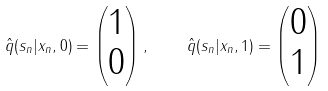<formula> <loc_0><loc_0><loc_500><loc_500>\hat { q } ( s _ { n } | x _ { n } , 0 ) = \begin{pmatrix} 1 \\ 0 \end{pmatrix} , \quad \hat { q } ( s _ { n } | x _ { n } , 1 ) = \begin{pmatrix} 0 \\ 1 \end{pmatrix}</formula> 